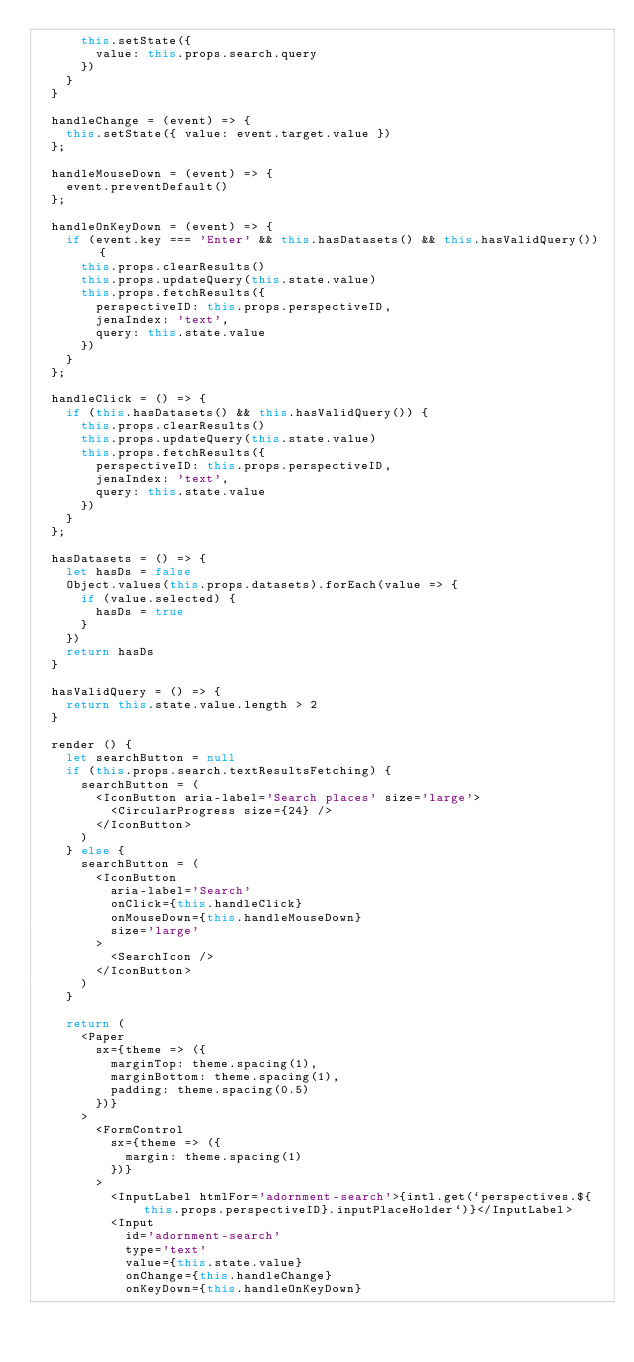<code> <loc_0><loc_0><loc_500><loc_500><_JavaScript_>      this.setState({
        value: this.props.search.query
      })
    }
  }

  handleChange = (event) => {
    this.setState({ value: event.target.value })
  };

  handleMouseDown = (event) => {
    event.preventDefault()
  };

  handleOnKeyDown = (event) => {
    if (event.key === 'Enter' && this.hasDatasets() && this.hasValidQuery()) {
      this.props.clearResults()
      this.props.updateQuery(this.state.value)
      this.props.fetchResults({
        perspectiveID: this.props.perspectiveID,
        jenaIndex: 'text',
        query: this.state.value
      })
    }
  };

  handleClick = () => {
    if (this.hasDatasets() && this.hasValidQuery()) {
      this.props.clearResults()
      this.props.updateQuery(this.state.value)
      this.props.fetchResults({
        perspectiveID: this.props.perspectiveID,
        jenaIndex: 'text',
        query: this.state.value
      })
    }
  };

  hasDatasets = () => {
    let hasDs = false
    Object.values(this.props.datasets).forEach(value => {
      if (value.selected) {
        hasDs = true
      }
    })
    return hasDs
  }

  hasValidQuery = () => {
    return this.state.value.length > 2
  }

  render () {
    let searchButton = null
    if (this.props.search.textResultsFetching) {
      searchButton = (
        <IconButton aria-label='Search places' size='large'>
          <CircularProgress size={24} />
        </IconButton>
      )
    } else {
      searchButton = (
        <IconButton
          aria-label='Search'
          onClick={this.handleClick}
          onMouseDown={this.handleMouseDown}
          size='large'
        >
          <SearchIcon />
        </IconButton>
      )
    }

    return (
      <Paper
        sx={theme => ({
          marginTop: theme.spacing(1),
          marginBottom: theme.spacing(1),
          padding: theme.spacing(0.5)
        })}
      >
        <FormControl
          sx={theme => ({
            margin: theme.spacing(1)
          })}
        >
          <InputLabel htmlFor='adornment-search'>{intl.get(`perspectives.${this.props.perspectiveID}.inputPlaceHolder`)}</InputLabel>
          <Input
            id='adornment-search'
            type='text'
            value={this.state.value}
            onChange={this.handleChange}
            onKeyDown={this.handleOnKeyDown}</code> 